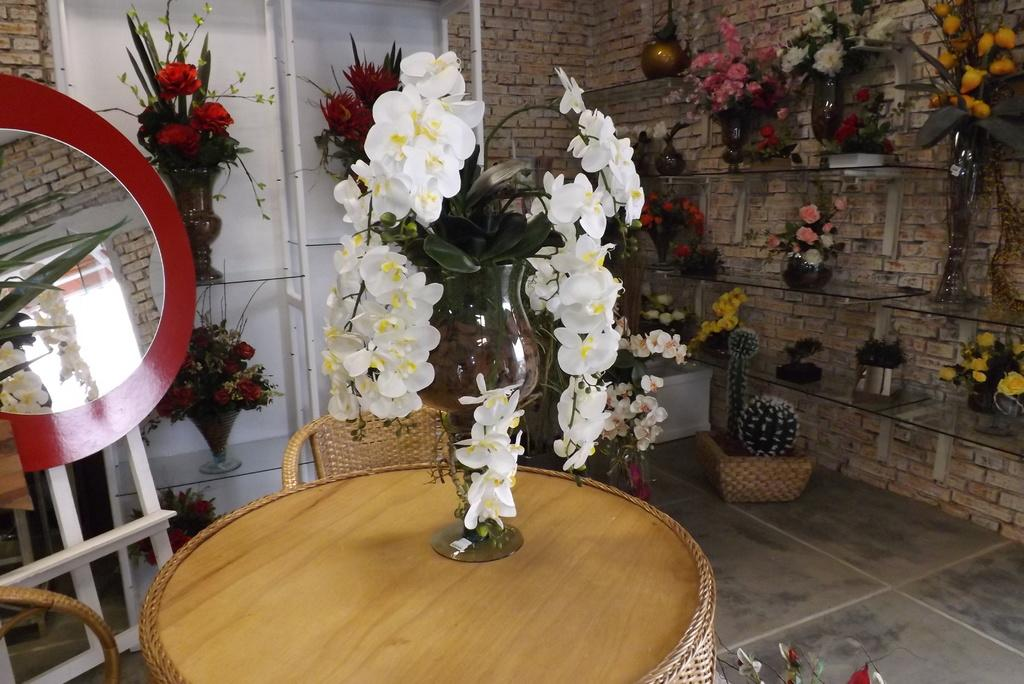What is placed on the floor in the image? There is a table on the floor in the image. What is on the table? There is a flower vase on the table. Can you describe any other furniture or structures in the image? Yes, there is a rack in the image. What is on the rack? There are vases on the rack. What is the wall in the background made of? The wall in the background is made of bricks. What type of oatmeal is being served in the jar on the table? There is no jar or oatmeal present in the image; it features a table, a flower vase, a rack, vases, and a brick wall. 